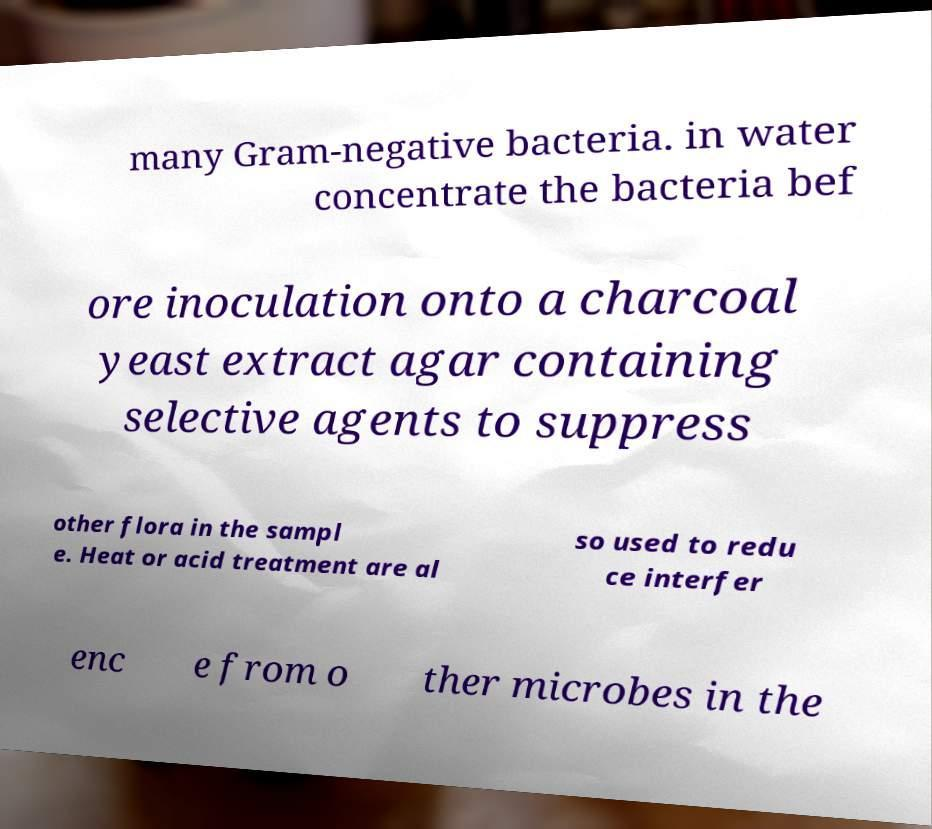What messages or text are displayed in this image? I need them in a readable, typed format. many Gram-negative bacteria. in water concentrate the bacteria bef ore inoculation onto a charcoal yeast extract agar containing selective agents to suppress other flora in the sampl e. Heat or acid treatment are al so used to redu ce interfer enc e from o ther microbes in the 